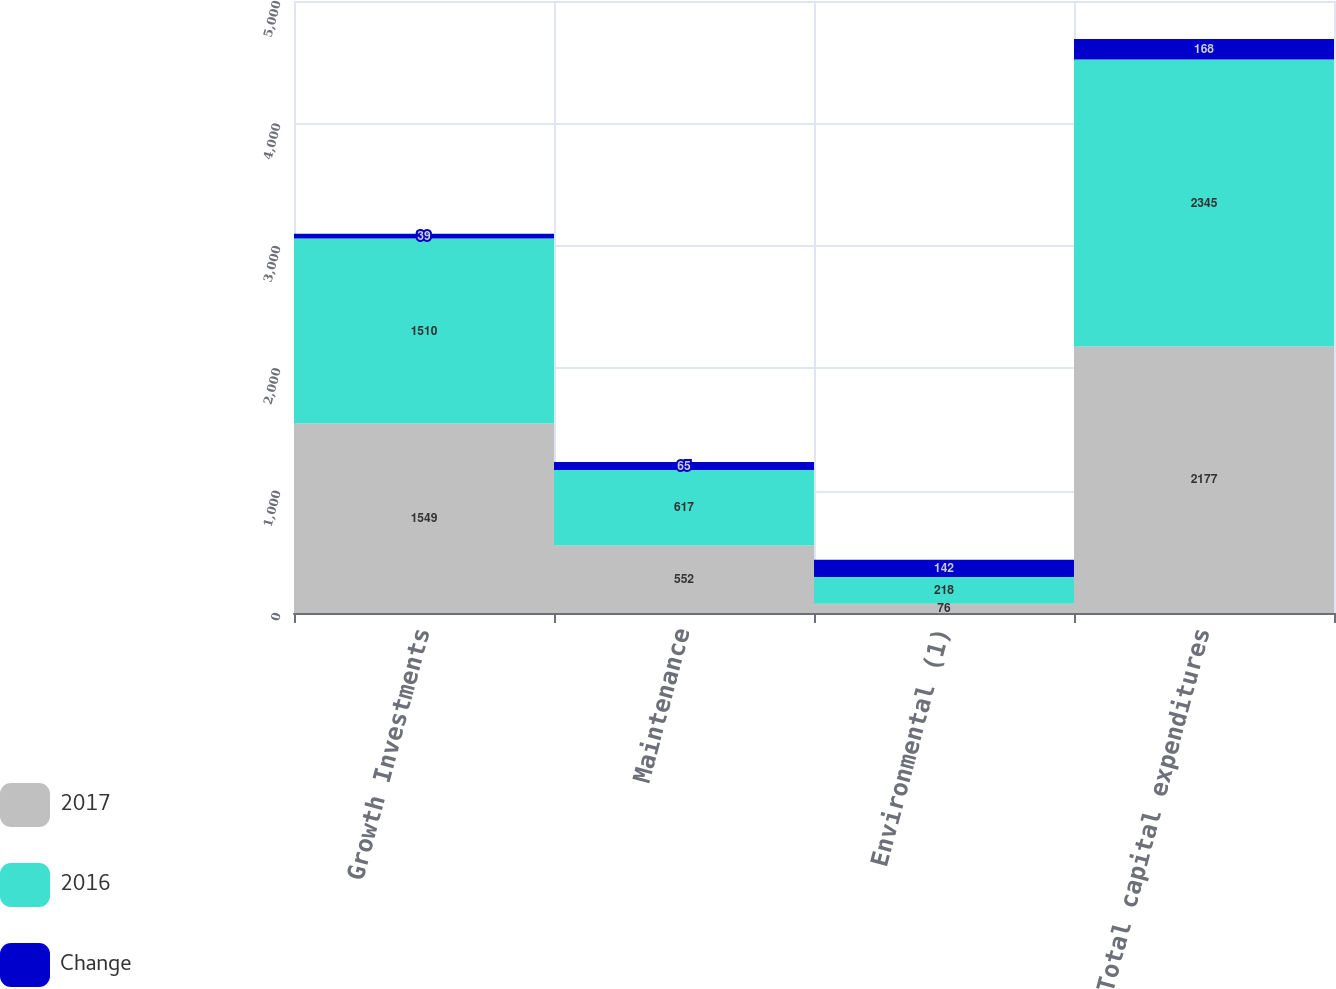Convert chart. <chart><loc_0><loc_0><loc_500><loc_500><stacked_bar_chart><ecel><fcel>Growth Investments<fcel>Maintenance<fcel>Environmental (1)<fcel>Total capital expenditures<nl><fcel>2017<fcel>1549<fcel>552<fcel>76<fcel>2177<nl><fcel>2016<fcel>1510<fcel>617<fcel>218<fcel>2345<nl><fcel>Change<fcel>39<fcel>65<fcel>142<fcel>168<nl></chart> 